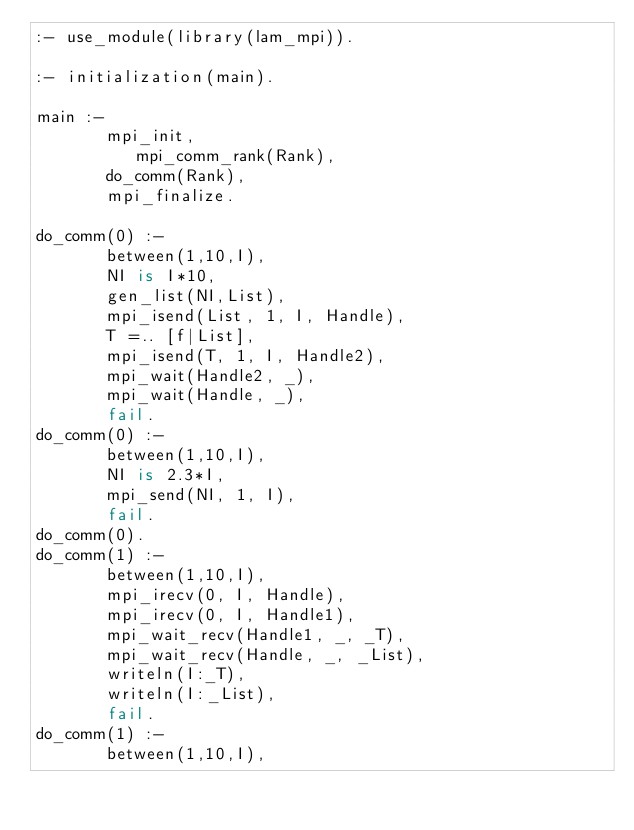Convert code to text. <code><loc_0><loc_0><loc_500><loc_500><_Prolog_>:- use_module(library(lam_mpi)).

:- initialization(main).

main :-
       mpi_init,
          mpi_comm_rank(Rank),
       do_comm(Rank),
       mpi_finalize.

do_comm(0) :-
	   between(1,10,I),
	   NI is I*10,
	   gen_list(NI,List),
	   mpi_isend(List, 1, I, Handle),
	   T =.. [f|List],
	   mpi_isend(T, 1, I, Handle2),
	   mpi_wait(Handle2, _),
	   mpi_wait(Handle, _),
   	   fail.
do_comm(0) :-
	   between(1,10,I),
	   NI is 2.3*I,
	   mpi_send(NI, 1, I),
	   fail.
do_comm(0).
do_comm(1) :-
	   between(1,10,I),
	   mpi_irecv(0, I, Handle),
	   mpi_irecv(0, I, Handle1),
	   mpi_wait_recv(Handle1, _, _T),
	   mpi_wait_recv(Handle, _, _List),
	   writeln(I:_T),
	   writeln(I:_List),
	   fail.
do_comm(1) :-
	   between(1,10,I),</code> 